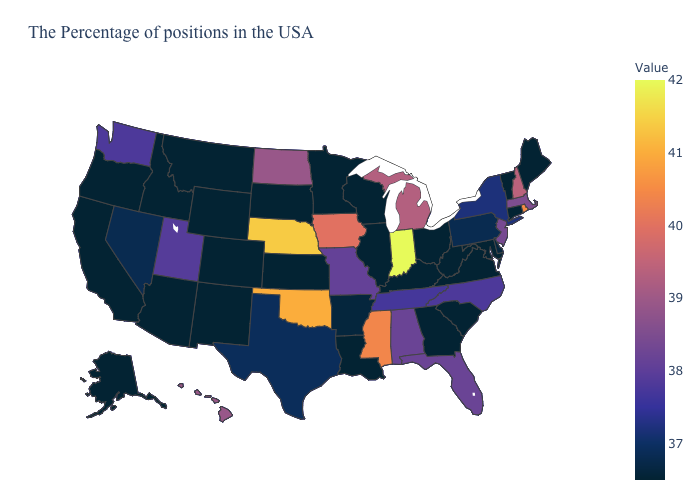Does Indiana have the highest value in the MidWest?
Be succinct. Yes. Does New Jersey have the lowest value in the USA?
Answer briefly. No. Which states have the lowest value in the South?
Concise answer only. Maryland, Virginia, South Carolina, West Virginia, Georgia, Kentucky, Louisiana. 